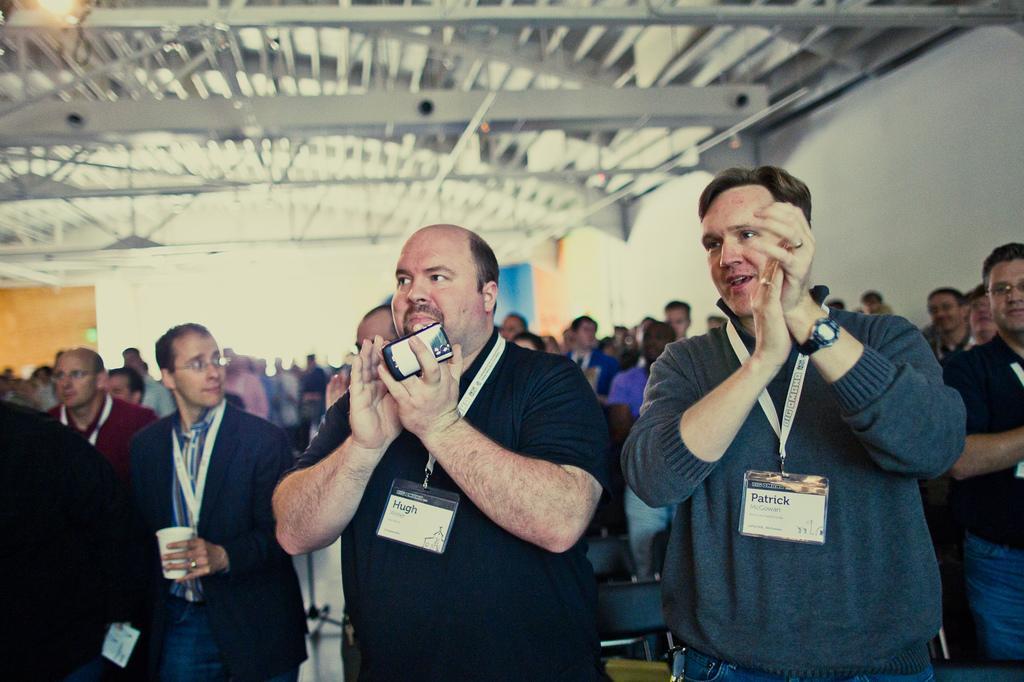Can you describe this image briefly? In this image, we can see many people and are wearing id cards and some are clapping and we can see a person holding a glass and there is an other person holding a mobile. In the background, there is a wall and at the top, there is light and there are rods and we can see roof. 